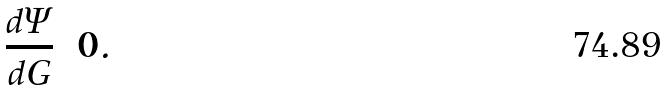<formula> <loc_0><loc_0><loc_500><loc_500>\frac { d \Psi } { d G } = 0 .</formula> 